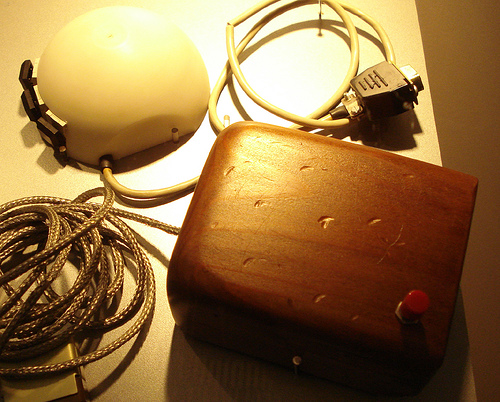<image>What is this equipment? The equipment is unknown, it can be computer, cords, cables or amplifier. What are the chords for? The chords' purpose is unknown. They could be for a hookup, a VGA display, power, connecting electricity, device connecting, or a computer. What is this equipment? I don't know what is this equipment. It can be a computer, cords, cables, clock or an amplifier. What are the chords for? I don't know what the chords are for. It can be used for hookup, power, device connecting, or to connect electricity. 